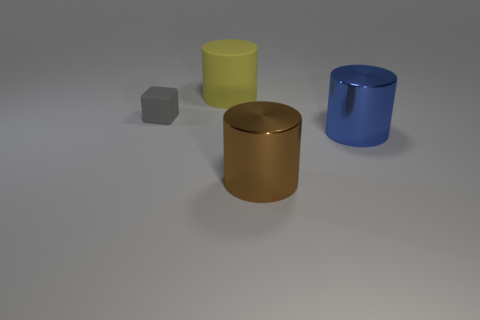The yellow cylinder that is made of the same material as the small gray thing is what size?
Keep it short and to the point. Large. Are there more small gray cubes in front of the small matte block than large rubber objects to the right of the yellow matte cylinder?
Your answer should be compact. No. What number of other objects are the same material as the big blue object?
Your answer should be compact. 1. Is the material of the thing that is behind the small matte cube the same as the gray object?
Ensure brevity in your answer.  Yes. What is the shape of the large yellow matte object?
Your response must be concise. Cylinder. Are there more big objects left of the blue metal thing than brown things?
Provide a succinct answer. Yes. Are there any other things that have the same shape as the big yellow object?
Make the answer very short. Yes. There is another metal object that is the same shape as the big blue thing; what is its color?
Offer a very short reply. Brown. There is a matte object in front of the large matte cylinder; what is its shape?
Your answer should be compact. Cube. Are there any large matte cylinders in front of the gray rubber block?
Keep it short and to the point. No. 